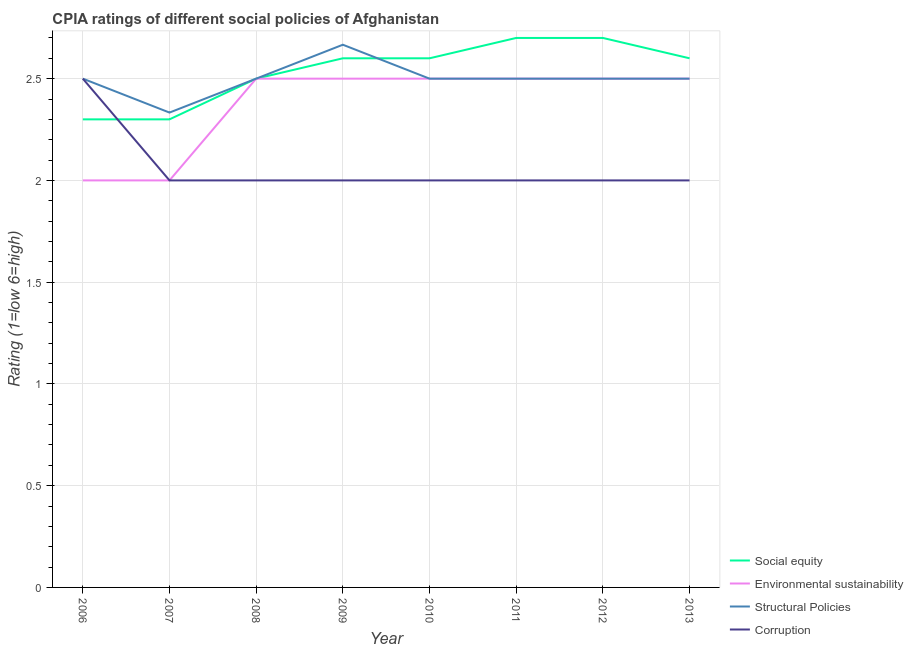Does the line corresponding to cpia rating of environmental sustainability intersect with the line corresponding to cpia rating of structural policies?
Offer a terse response. Yes. In which year was the cpia rating of structural policies maximum?
Keep it short and to the point. 2009. In which year was the cpia rating of corruption minimum?
Your response must be concise. 2007. What is the total cpia rating of environmental sustainability in the graph?
Ensure brevity in your answer.  19. What is the difference between the cpia rating of structural policies in 2009 and that in 2010?
Keep it short and to the point. 0.17. What is the difference between the cpia rating of environmental sustainability in 2011 and the cpia rating of structural policies in 2009?
Make the answer very short. -0.17. What is the average cpia rating of corruption per year?
Keep it short and to the point. 2.06. In the year 2011, what is the difference between the cpia rating of structural policies and cpia rating of corruption?
Provide a short and direct response. 0.5. In how many years, is the cpia rating of social equity greater than 0.9?
Provide a succinct answer. 8. What is the ratio of the cpia rating of environmental sustainability in 2010 to that in 2012?
Your answer should be very brief. 1. What is the difference between the highest and the second highest cpia rating of social equity?
Provide a succinct answer. 0. What is the difference between the highest and the lowest cpia rating of social equity?
Offer a terse response. 0.4. Does the cpia rating of environmental sustainability monotonically increase over the years?
Your answer should be very brief. No. What is the difference between two consecutive major ticks on the Y-axis?
Provide a short and direct response. 0.5. Where does the legend appear in the graph?
Make the answer very short. Bottom right. How many legend labels are there?
Ensure brevity in your answer.  4. What is the title of the graph?
Ensure brevity in your answer.  CPIA ratings of different social policies of Afghanistan. Does "Grants and Revenue" appear as one of the legend labels in the graph?
Your response must be concise. No. What is the label or title of the Y-axis?
Give a very brief answer. Rating (1=low 6=high). What is the Rating (1=low 6=high) of Social equity in 2006?
Provide a short and direct response. 2.3. What is the Rating (1=low 6=high) in Environmental sustainability in 2006?
Provide a short and direct response. 2. What is the Rating (1=low 6=high) of Corruption in 2006?
Keep it short and to the point. 2.5. What is the Rating (1=low 6=high) in Environmental sustainability in 2007?
Offer a very short reply. 2. What is the Rating (1=low 6=high) in Structural Policies in 2007?
Provide a short and direct response. 2.33. What is the Rating (1=low 6=high) in Social equity in 2008?
Give a very brief answer. 2.5. What is the Rating (1=low 6=high) in Structural Policies in 2008?
Your response must be concise. 2.5. What is the Rating (1=low 6=high) of Corruption in 2008?
Provide a succinct answer. 2. What is the Rating (1=low 6=high) of Structural Policies in 2009?
Provide a succinct answer. 2.67. What is the Rating (1=low 6=high) in Corruption in 2009?
Ensure brevity in your answer.  2. What is the Rating (1=low 6=high) of Structural Policies in 2010?
Ensure brevity in your answer.  2.5. What is the Rating (1=low 6=high) in Corruption in 2010?
Provide a short and direct response. 2. What is the Rating (1=low 6=high) of Structural Policies in 2011?
Offer a terse response. 2.5. What is the Rating (1=low 6=high) of Social equity in 2012?
Provide a short and direct response. 2.7. What is the Rating (1=low 6=high) of Social equity in 2013?
Your response must be concise. 2.6. What is the Rating (1=low 6=high) in Corruption in 2013?
Ensure brevity in your answer.  2. Across all years, what is the maximum Rating (1=low 6=high) of Social equity?
Provide a short and direct response. 2.7. Across all years, what is the maximum Rating (1=low 6=high) in Environmental sustainability?
Offer a terse response. 2.5. Across all years, what is the maximum Rating (1=low 6=high) of Structural Policies?
Provide a short and direct response. 2.67. Across all years, what is the maximum Rating (1=low 6=high) of Corruption?
Offer a terse response. 2.5. Across all years, what is the minimum Rating (1=low 6=high) of Social equity?
Provide a succinct answer. 2.3. Across all years, what is the minimum Rating (1=low 6=high) of Environmental sustainability?
Make the answer very short. 2. Across all years, what is the minimum Rating (1=low 6=high) in Structural Policies?
Your answer should be compact. 2.33. Across all years, what is the minimum Rating (1=low 6=high) of Corruption?
Provide a short and direct response. 2. What is the total Rating (1=low 6=high) of Social equity in the graph?
Make the answer very short. 20.3. What is the total Rating (1=low 6=high) in Structural Policies in the graph?
Offer a very short reply. 20. What is the difference between the Rating (1=low 6=high) in Social equity in 2006 and that in 2007?
Make the answer very short. 0. What is the difference between the Rating (1=low 6=high) of Environmental sustainability in 2006 and that in 2007?
Give a very brief answer. 0. What is the difference between the Rating (1=low 6=high) in Corruption in 2006 and that in 2007?
Ensure brevity in your answer.  0.5. What is the difference between the Rating (1=low 6=high) of Environmental sustainability in 2006 and that in 2008?
Offer a very short reply. -0.5. What is the difference between the Rating (1=low 6=high) in Structural Policies in 2006 and that in 2008?
Provide a short and direct response. 0. What is the difference between the Rating (1=low 6=high) of Structural Policies in 2006 and that in 2009?
Your answer should be compact. -0.17. What is the difference between the Rating (1=low 6=high) of Social equity in 2006 and that in 2010?
Offer a very short reply. -0.3. What is the difference between the Rating (1=low 6=high) in Structural Policies in 2006 and that in 2010?
Offer a terse response. 0. What is the difference between the Rating (1=low 6=high) of Corruption in 2006 and that in 2011?
Make the answer very short. 0.5. What is the difference between the Rating (1=low 6=high) of Environmental sustainability in 2006 and that in 2012?
Your answer should be compact. -0.5. What is the difference between the Rating (1=low 6=high) of Corruption in 2006 and that in 2012?
Provide a succinct answer. 0.5. What is the difference between the Rating (1=low 6=high) in Social equity in 2006 and that in 2013?
Offer a terse response. -0.3. What is the difference between the Rating (1=low 6=high) in Structural Policies in 2006 and that in 2013?
Provide a succinct answer. 0. What is the difference between the Rating (1=low 6=high) in Corruption in 2006 and that in 2013?
Offer a very short reply. 0.5. What is the difference between the Rating (1=low 6=high) in Social equity in 2007 and that in 2009?
Give a very brief answer. -0.3. What is the difference between the Rating (1=low 6=high) in Structural Policies in 2007 and that in 2009?
Provide a succinct answer. -0.33. What is the difference between the Rating (1=low 6=high) in Corruption in 2007 and that in 2009?
Your answer should be very brief. 0. What is the difference between the Rating (1=low 6=high) of Social equity in 2007 and that in 2010?
Give a very brief answer. -0.3. What is the difference between the Rating (1=low 6=high) in Environmental sustainability in 2007 and that in 2010?
Ensure brevity in your answer.  -0.5. What is the difference between the Rating (1=low 6=high) of Social equity in 2007 and that in 2011?
Keep it short and to the point. -0.4. What is the difference between the Rating (1=low 6=high) of Social equity in 2007 and that in 2012?
Offer a terse response. -0.4. What is the difference between the Rating (1=low 6=high) in Environmental sustainability in 2007 and that in 2013?
Offer a very short reply. -0.5. What is the difference between the Rating (1=low 6=high) of Structural Policies in 2007 and that in 2013?
Your answer should be compact. -0.17. What is the difference between the Rating (1=low 6=high) in Social equity in 2008 and that in 2009?
Give a very brief answer. -0.1. What is the difference between the Rating (1=low 6=high) in Environmental sustainability in 2008 and that in 2009?
Offer a terse response. 0. What is the difference between the Rating (1=low 6=high) in Social equity in 2008 and that in 2010?
Your answer should be very brief. -0.1. What is the difference between the Rating (1=low 6=high) of Social equity in 2008 and that in 2011?
Your answer should be compact. -0.2. What is the difference between the Rating (1=low 6=high) in Corruption in 2008 and that in 2011?
Make the answer very short. 0. What is the difference between the Rating (1=low 6=high) of Social equity in 2008 and that in 2012?
Keep it short and to the point. -0.2. What is the difference between the Rating (1=low 6=high) of Social equity in 2008 and that in 2013?
Ensure brevity in your answer.  -0.1. What is the difference between the Rating (1=low 6=high) in Environmental sustainability in 2008 and that in 2013?
Your answer should be very brief. 0. What is the difference between the Rating (1=low 6=high) in Social equity in 2009 and that in 2010?
Provide a succinct answer. 0. What is the difference between the Rating (1=low 6=high) of Structural Policies in 2009 and that in 2010?
Your response must be concise. 0.17. What is the difference between the Rating (1=low 6=high) of Corruption in 2009 and that in 2010?
Your response must be concise. 0. What is the difference between the Rating (1=low 6=high) of Corruption in 2009 and that in 2011?
Give a very brief answer. 0. What is the difference between the Rating (1=low 6=high) of Environmental sustainability in 2009 and that in 2012?
Give a very brief answer. 0. What is the difference between the Rating (1=low 6=high) of Structural Policies in 2009 and that in 2012?
Your response must be concise. 0.17. What is the difference between the Rating (1=low 6=high) in Social equity in 2009 and that in 2013?
Your answer should be very brief. 0. What is the difference between the Rating (1=low 6=high) in Corruption in 2009 and that in 2013?
Your response must be concise. 0. What is the difference between the Rating (1=low 6=high) in Structural Policies in 2010 and that in 2011?
Your answer should be very brief. 0. What is the difference between the Rating (1=low 6=high) of Social equity in 2010 and that in 2012?
Offer a terse response. -0.1. What is the difference between the Rating (1=low 6=high) in Environmental sustainability in 2010 and that in 2012?
Your response must be concise. 0. What is the difference between the Rating (1=low 6=high) in Structural Policies in 2010 and that in 2012?
Your response must be concise. 0. What is the difference between the Rating (1=low 6=high) in Environmental sustainability in 2010 and that in 2013?
Offer a very short reply. 0. What is the difference between the Rating (1=low 6=high) of Social equity in 2011 and that in 2012?
Give a very brief answer. 0. What is the difference between the Rating (1=low 6=high) of Environmental sustainability in 2011 and that in 2012?
Make the answer very short. 0. What is the difference between the Rating (1=low 6=high) of Structural Policies in 2011 and that in 2012?
Your response must be concise. 0. What is the difference between the Rating (1=low 6=high) in Corruption in 2011 and that in 2012?
Make the answer very short. 0. What is the difference between the Rating (1=low 6=high) of Social equity in 2011 and that in 2013?
Offer a very short reply. 0.1. What is the difference between the Rating (1=low 6=high) in Environmental sustainability in 2011 and that in 2013?
Provide a succinct answer. 0. What is the difference between the Rating (1=low 6=high) of Structural Policies in 2011 and that in 2013?
Your answer should be compact. 0. What is the difference between the Rating (1=low 6=high) of Social equity in 2012 and that in 2013?
Offer a very short reply. 0.1. What is the difference between the Rating (1=low 6=high) of Social equity in 2006 and the Rating (1=low 6=high) of Environmental sustainability in 2007?
Provide a short and direct response. 0.3. What is the difference between the Rating (1=low 6=high) of Social equity in 2006 and the Rating (1=low 6=high) of Structural Policies in 2007?
Your answer should be very brief. -0.03. What is the difference between the Rating (1=low 6=high) of Social equity in 2006 and the Rating (1=low 6=high) of Corruption in 2007?
Your response must be concise. 0.3. What is the difference between the Rating (1=low 6=high) of Environmental sustainability in 2006 and the Rating (1=low 6=high) of Structural Policies in 2007?
Offer a terse response. -0.33. What is the difference between the Rating (1=low 6=high) of Environmental sustainability in 2006 and the Rating (1=low 6=high) of Corruption in 2007?
Your response must be concise. 0. What is the difference between the Rating (1=low 6=high) in Social equity in 2006 and the Rating (1=low 6=high) in Corruption in 2008?
Your response must be concise. 0.3. What is the difference between the Rating (1=low 6=high) in Environmental sustainability in 2006 and the Rating (1=low 6=high) in Structural Policies in 2008?
Provide a short and direct response. -0.5. What is the difference between the Rating (1=low 6=high) in Environmental sustainability in 2006 and the Rating (1=low 6=high) in Corruption in 2008?
Give a very brief answer. 0. What is the difference between the Rating (1=low 6=high) in Social equity in 2006 and the Rating (1=low 6=high) in Environmental sustainability in 2009?
Keep it short and to the point. -0.2. What is the difference between the Rating (1=low 6=high) of Social equity in 2006 and the Rating (1=low 6=high) of Structural Policies in 2009?
Your answer should be compact. -0.37. What is the difference between the Rating (1=low 6=high) of Social equity in 2006 and the Rating (1=low 6=high) of Corruption in 2009?
Your response must be concise. 0.3. What is the difference between the Rating (1=low 6=high) of Structural Policies in 2006 and the Rating (1=low 6=high) of Corruption in 2009?
Offer a very short reply. 0.5. What is the difference between the Rating (1=low 6=high) in Social equity in 2006 and the Rating (1=low 6=high) in Environmental sustainability in 2010?
Your answer should be compact. -0.2. What is the difference between the Rating (1=low 6=high) of Social equity in 2006 and the Rating (1=low 6=high) of Structural Policies in 2010?
Provide a succinct answer. -0.2. What is the difference between the Rating (1=low 6=high) in Social equity in 2006 and the Rating (1=low 6=high) in Corruption in 2010?
Provide a short and direct response. 0.3. What is the difference between the Rating (1=low 6=high) in Environmental sustainability in 2006 and the Rating (1=low 6=high) in Corruption in 2010?
Your response must be concise. 0. What is the difference between the Rating (1=low 6=high) of Structural Policies in 2006 and the Rating (1=low 6=high) of Corruption in 2010?
Your response must be concise. 0.5. What is the difference between the Rating (1=low 6=high) of Social equity in 2006 and the Rating (1=low 6=high) of Environmental sustainability in 2011?
Ensure brevity in your answer.  -0.2. What is the difference between the Rating (1=low 6=high) in Social equity in 2006 and the Rating (1=low 6=high) in Structural Policies in 2011?
Keep it short and to the point. -0.2. What is the difference between the Rating (1=low 6=high) of Social equity in 2006 and the Rating (1=low 6=high) of Corruption in 2011?
Offer a very short reply. 0.3. What is the difference between the Rating (1=low 6=high) in Environmental sustainability in 2006 and the Rating (1=low 6=high) in Structural Policies in 2011?
Keep it short and to the point. -0.5. What is the difference between the Rating (1=low 6=high) in Social equity in 2006 and the Rating (1=low 6=high) in Structural Policies in 2012?
Ensure brevity in your answer.  -0.2. What is the difference between the Rating (1=low 6=high) in Structural Policies in 2006 and the Rating (1=low 6=high) in Corruption in 2012?
Offer a very short reply. 0.5. What is the difference between the Rating (1=low 6=high) in Social equity in 2006 and the Rating (1=low 6=high) in Environmental sustainability in 2013?
Give a very brief answer. -0.2. What is the difference between the Rating (1=low 6=high) in Environmental sustainability in 2006 and the Rating (1=low 6=high) in Structural Policies in 2013?
Give a very brief answer. -0.5. What is the difference between the Rating (1=low 6=high) in Social equity in 2007 and the Rating (1=low 6=high) in Structural Policies in 2008?
Offer a terse response. -0.2. What is the difference between the Rating (1=low 6=high) of Social equity in 2007 and the Rating (1=low 6=high) of Corruption in 2008?
Offer a terse response. 0.3. What is the difference between the Rating (1=low 6=high) in Social equity in 2007 and the Rating (1=low 6=high) in Structural Policies in 2009?
Keep it short and to the point. -0.37. What is the difference between the Rating (1=low 6=high) in Environmental sustainability in 2007 and the Rating (1=low 6=high) in Corruption in 2009?
Ensure brevity in your answer.  0. What is the difference between the Rating (1=low 6=high) in Structural Policies in 2007 and the Rating (1=low 6=high) in Corruption in 2009?
Offer a terse response. 0.33. What is the difference between the Rating (1=low 6=high) of Social equity in 2007 and the Rating (1=low 6=high) of Environmental sustainability in 2010?
Give a very brief answer. -0.2. What is the difference between the Rating (1=low 6=high) in Environmental sustainability in 2007 and the Rating (1=low 6=high) in Structural Policies in 2010?
Make the answer very short. -0.5. What is the difference between the Rating (1=low 6=high) of Environmental sustainability in 2007 and the Rating (1=low 6=high) of Corruption in 2010?
Your answer should be very brief. 0. What is the difference between the Rating (1=low 6=high) in Structural Policies in 2007 and the Rating (1=low 6=high) in Corruption in 2010?
Offer a terse response. 0.33. What is the difference between the Rating (1=low 6=high) of Social equity in 2007 and the Rating (1=low 6=high) of Environmental sustainability in 2011?
Provide a short and direct response. -0.2. What is the difference between the Rating (1=low 6=high) in Structural Policies in 2007 and the Rating (1=low 6=high) in Corruption in 2011?
Your response must be concise. 0.33. What is the difference between the Rating (1=low 6=high) in Social equity in 2007 and the Rating (1=low 6=high) in Environmental sustainability in 2012?
Give a very brief answer. -0.2. What is the difference between the Rating (1=low 6=high) in Social equity in 2007 and the Rating (1=low 6=high) in Structural Policies in 2012?
Make the answer very short. -0.2. What is the difference between the Rating (1=low 6=high) of Social equity in 2007 and the Rating (1=low 6=high) of Corruption in 2012?
Provide a succinct answer. 0.3. What is the difference between the Rating (1=low 6=high) of Environmental sustainability in 2007 and the Rating (1=low 6=high) of Structural Policies in 2012?
Your response must be concise. -0.5. What is the difference between the Rating (1=low 6=high) of Environmental sustainability in 2007 and the Rating (1=low 6=high) of Corruption in 2012?
Keep it short and to the point. 0. What is the difference between the Rating (1=low 6=high) of Structural Policies in 2007 and the Rating (1=low 6=high) of Corruption in 2012?
Provide a short and direct response. 0.33. What is the difference between the Rating (1=low 6=high) in Social equity in 2007 and the Rating (1=low 6=high) in Environmental sustainability in 2013?
Give a very brief answer. -0.2. What is the difference between the Rating (1=low 6=high) of Social equity in 2007 and the Rating (1=low 6=high) of Structural Policies in 2013?
Provide a succinct answer. -0.2. What is the difference between the Rating (1=low 6=high) of Social equity in 2007 and the Rating (1=low 6=high) of Corruption in 2013?
Give a very brief answer. 0.3. What is the difference between the Rating (1=low 6=high) in Environmental sustainability in 2007 and the Rating (1=low 6=high) in Structural Policies in 2013?
Provide a succinct answer. -0.5. What is the difference between the Rating (1=low 6=high) in Social equity in 2008 and the Rating (1=low 6=high) in Structural Policies in 2009?
Ensure brevity in your answer.  -0.17. What is the difference between the Rating (1=low 6=high) of Environmental sustainability in 2008 and the Rating (1=low 6=high) of Corruption in 2009?
Give a very brief answer. 0.5. What is the difference between the Rating (1=low 6=high) in Structural Policies in 2008 and the Rating (1=low 6=high) in Corruption in 2009?
Your answer should be compact. 0.5. What is the difference between the Rating (1=low 6=high) in Social equity in 2008 and the Rating (1=low 6=high) in Environmental sustainability in 2010?
Provide a succinct answer. 0. What is the difference between the Rating (1=low 6=high) of Environmental sustainability in 2008 and the Rating (1=low 6=high) of Structural Policies in 2010?
Your response must be concise. 0. What is the difference between the Rating (1=low 6=high) of Environmental sustainability in 2008 and the Rating (1=low 6=high) of Corruption in 2010?
Your answer should be compact. 0.5. What is the difference between the Rating (1=low 6=high) of Social equity in 2008 and the Rating (1=low 6=high) of Environmental sustainability in 2011?
Ensure brevity in your answer.  0. What is the difference between the Rating (1=low 6=high) in Social equity in 2008 and the Rating (1=low 6=high) in Corruption in 2011?
Your response must be concise. 0.5. What is the difference between the Rating (1=low 6=high) of Environmental sustainability in 2008 and the Rating (1=low 6=high) of Structural Policies in 2011?
Offer a very short reply. 0. What is the difference between the Rating (1=low 6=high) of Environmental sustainability in 2008 and the Rating (1=low 6=high) of Corruption in 2011?
Provide a succinct answer. 0.5. What is the difference between the Rating (1=low 6=high) in Environmental sustainability in 2008 and the Rating (1=low 6=high) in Structural Policies in 2012?
Your response must be concise. 0. What is the difference between the Rating (1=low 6=high) of Environmental sustainability in 2008 and the Rating (1=low 6=high) of Corruption in 2012?
Offer a terse response. 0.5. What is the difference between the Rating (1=low 6=high) in Structural Policies in 2008 and the Rating (1=low 6=high) in Corruption in 2012?
Keep it short and to the point. 0.5. What is the difference between the Rating (1=low 6=high) of Social equity in 2008 and the Rating (1=low 6=high) of Environmental sustainability in 2013?
Provide a succinct answer. 0. What is the difference between the Rating (1=low 6=high) in Social equity in 2008 and the Rating (1=low 6=high) in Corruption in 2013?
Provide a short and direct response. 0.5. What is the difference between the Rating (1=low 6=high) in Environmental sustainability in 2009 and the Rating (1=low 6=high) in Structural Policies in 2010?
Your response must be concise. 0. What is the difference between the Rating (1=low 6=high) in Structural Policies in 2009 and the Rating (1=low 6=high) in Corruption in 2010?
Your answer should be compact. 0.67. What is the difference between the Rating (1=low 6=high) of Social equity in 2009 and the Rating (1=low 6=high) of Structural Policies in 2011?
Make the answer very short. 0.1. What is the difference between the Rating (1=low 6=high) in Social equity in 2009 and the Rating (1=low 6=high) in Corruption in 2011?
Ensure brevity in your answer.  0.6. What is the difference between the Rating (1=low 6=high) of Structural Policies in 2009 and the Rating (1=low 6=high) of Corruption in 2011?
Ensure brevity in your answer.  0.67. What is the difference between the Rating (1=low 6=high) of Social equity in 2009 and the Rating (1=low 6=high) of Environmental sustainability in 2012?
Make the answer very short. 0.1. What is the difference between the Rating (1=low 6=high) of Environmental sustainability in 2009 and the Rating (1=low 6=high) of Corruption in 2012?
Provide a short and direct response. 0.5. What is the difference between the Rating (1=low 6=high) in Structural Policies in 2009 and the Rating (1=low 6=high) in Corruption in 2012?
Provide a succinct answer. 0.67. What is the difference between the Rating (1=low 6=high) of Social equity in 2009 and the Rating (1=low 6=high) of Environmental sustainability in 2013?
Provide a short and direct response. 0.1. What is the difference between the Rating (1=low 6=high) in Environmental sustainability in 2009 and the Rating (1=low 6=high) in Corruption in 2013?
Provide a short and direct response. 0.5. What is the difference between the Rating (1=low 6=high) of Structural Policies in 2009 and the Rating (1=low 6=high) of Corruption in 2013?
Make the answer very short. 0.67. What is the difference between the Rating (1=low 6=high) of Social equity in 2010 and the Rating (1=low 6=high) of Structural Policies in 2011?
Ensure brevity in your answer.  0.1. What is the difference between the Rating (1=low 6=high) in Social equity in 2010 and the Rating (1=low 6=high) in Corruption in 2011?
Your answer should be very brief. 0.6. What is the difference between the Rating (1=low 6=high) in Environmental sustainability in 2010 and the Rating (1=low 6=high) in Structural Policies in 2011?
Give a very brief answer. 0. What is the difference between the Rating (1=low 6=high) in Social equity in 2010 and the Rating (1=low 6=high) in Environmental sustainability in 2012?
Make the answer very short. 0.1. What is the difference between the Rating (1=low 6=high) in Social equity in 2010 and the Rating (1=low 6=high) in Structural Policies in 2012?
Make the answer very short. 0.1. What is the difference between the Rating (1=low 6=high) in Environmental sustainability in 2010 and the Rating (1=low 6=high) in Structural Policies in 2012?
Offer a terse response. 0. What is the difference between the Rating (1=low 6=high) of Environmental sustainability in 2010 and the Rating (1=low 6=high) of Corruption in 2012?
Give a very brief answer. 0.5. What is the difference between the Rating (1=low 6=high) of Social equity in 2010 and the Rating (1=low 6=high) of Environmental sustainability in 2013?
Ensure brevity in your answer.  0.1. What is the difference between the Rating (1=low 6=high) of Social equity in 2010 and the Rating (1=low 6=high) of Structural Policies in 2013?
Offer a very short reply. 0.1. What is the difference between the Rating (1=low 6=high) of Social equity in 2010 and the Rating (1=low 6=high) of Corruption in 2013?
Provide a succinct answer. 0.6. What is the difference between the Rating (1=low 6=high) in Structural Policies in 2010 and the Rating (1=low 6=high) in Corruption in 2013?
Your response must be concise. 0.5. What is the difference between the Rating (1=low 6=high) of Social equity in 2011 and the Rating (1=low 6=high) of Structural Policies in 2012?
Your answer should be compact. 0.2. What is the difference between the Rating (1=low 6=high) in Environmental sustainability in 2011 and the Rating (1=low 6=high) in Structural Policies in 2012?
Ensure brevity in your answer.  0. What is the difference between the Rating (1=low 6=high) in Environmental sustainability in 2011 and the Rating (1=low 6=high) in Structural Policies in 2013?
Ensure brevity in your answer.  0. What is the difference between the Rating (1=low 6=high) of Structural Policies in 2011 and the Rating (1=low 6=high) of Corruption in 2013?
Provide a succinct answer. 0.5. What is the difference between the Rating (1=low 6=high) in Social equity in 2012 and the Rating (1=low 6=high) in Structural Policies in 2013?
Provide a succinct answer. 0.2. What is the difference between the Rating (1=low 6=high) in Social equity in 2012 and the Rating (1=low 6=high) in Corruption in 2013?
Your response must be concise. 0.7. What is the difference between the Rating (1=low 6=high) in Environmental sustainability in 2012 and the Rating (1=low 6=high) in Structural Policies in 2013?
Your answer should be very brief. 0. What is the difference between the Rating (1=low 6=high) of Environmental sustainability in 2012 and the Rating (1=low 6=high) of Corruption in 2013?
Provide a succinct answer. 0.5. What is the average Rating (1=low 6=high) in Social equity per year?
Provide a short and direct response. 2.54. What is the average Rating (1=low 6=high) in Environmental sustainability per year?
Provide a short and direct response. 2.38. What is the average Rating (1=low 6=high) of Corruption per year?
Keep it short and to the point. 2.06. In the year 2006, what is the difference between the Rating (1=low 6=high) of Social equity and Rating (1=low 6=high) of Corruption?
Offer a terse response. -0.2. In the year 2006, what is the difference between the Rating (1=low 6=high) of Environmental sustainability and Rating (1=low 6=high) of Corruption?
Your answer should be very brief. -0.5. In the year 2007, what is the difference between the Rating (1=low 6=high) of Social equity and Rating (1=low 6=high) of Environmental sustainability?
Your response must be concise. 0.3. In the year 2007, what is the difference between the Rating (1=low 6=high) in Social equity and Rating (1=low 6=high) in Structural Policies?
Your answer should be very brief. -0.03. In the year 2007, what is the difference between the Rating (1=low 6=high) of Environmental sustainability and Rating (1=low 6=high) of Corruption?
Your answer should be compact. 0. In the year 2007, what is the difference between the Rating (1=low 6=high) in Structural Policies and Rating (1=low 6=high) in Corruption?
Give a very brief answer. 0.33. In the year 2008, what is the difference between the Rating (1=low 6=high) in Social equity and Rating (1=low 6=high) in Corruption?
Ensure brevity in your answer.  0.5. In the year 2008, what is the difference between the Rating (1=low 6=high) of Structural Policies and Rating (1=low 6=high) of Corruption?
Provide a succinct answer. 0.5. In the year 2009, what is the difference between the Rating (1=low 6=high) of Social equity and Rating (1=low 6=high) of Environmental sustainability?
Your answer should be very brief. 0.1. In the year 2009, what is the difference between the Rating (1=low 6=high) in Social equity and Rating (1=low 6=high) in Structural Policies?
Ensure brevity in your answer.  -0.07. In the year 2009, what is the difference between the Rating (1=low 6=high) of Environmental sustainability and Rating (1=low 6=high) of Corruption?
Offer a terse response. 0.5. In the year 2009, what is the difference between the Rating (1=low 6=high) in Structural Policies and Rating (1=low 6=high) in Corruption?
Provide a succinct answer. 0.67. In the year 2010, what is the difference between the Rating (1=low 6=high) in Structural Policies and Rating (1=low 6=high) in Corruption?
Your answer should be compact. 0.5. In the year 2011, what is the difference between the Rating (1=low 6=high) in Social equity and Rating (1=low 6=high) in Environmental sustainability?
Provide a short and direct response. 0.2. In the year 2011, what is the difference between the Rating (1=low 6=high) of Social equity and Rating (1=low 6=high) of Structural Policies?
Keep it short and to the point. 0.2. In the year 2011, what is the difference between the Rating (1=low 6=high) of Social equity and Rating (1=low 6=high) of Corruption?
Make the answer very short. 0.7. In the year 2012, what is the difference between the Rating (1=low 6=high) in Social equity and Rating (1=low 6=high) in Environmental sustainability?
Ensure brevity in your answer.  0.2. In the year 2012, what is the difference between the Rating (1=low 6=high) in Social equity and Rating (1=low 6=high) in Structural Policies?
Offer a terse response. 0.2. In the year 2012, what is the difference between the Rating (1=low 6=high) in Social equity and Rating (1=low 6=high) in Corruption?
Provide a short and direct response. 0.7. In the year 2012, what is the difference between the Rating (1=low 6=high) of Environmental sustainability and Rating (1=low 6=high) of Structural Policies?
Keep it short and to the point. 0. In the year 2013, what is the difference between the Rating (1=low 6=high) in Social equity and Rating (1=low 6=high) in Environmental sustainability?
Ensure brevity in your answer.  0.1. In the year 2013, what is the difference between the Rating (1=low 6=high) in Social equity and Rating (1=low 6=high) in Structural Policies?
Provide a short and direct response. 0.1. In the year 2013, what is the difference between the Rating (1=low 6=high) of Environmental sustainability and Rating (1=low 6=high) of Structural Policies?
Ensure brevity in your answer.  0. What is the ratio of the Rating (1=low 6=high) of Social equity in 2006 to that in 2007?
Make the answer very short. 1. What is the ratio of the Rating (1=low 6=high) in Structural Policies in 2006 to that in 2007?
Provide a succinct answer. 1.07. What is the ratio of the Rating (1=low 6=high) of Corruption in 2006 to that in 2007?
Your answer should be compact. 1.25. What is the ratio of the Rating (1=low 6=high) in Structural Policies in 2006 to that in 2008?
Ensure brevity in your answer.  1. What is the ratio of the Rating (1=low 6=high) in Corruption in 2006 to that in 2008?
Give a very brief answer. 1.25. What is the ratio of the Rating (1=low 6=high) in Social equity in 2006 to that in 2009?
Your answer should be compact. 0.88. What is the ratio of the Rating (1=low 6=high) in Structural Policies in 2006 to that in 2009?
Give a very brief answer. 0.94. What is the ratio of the Rating (1=low 6=high) in Social equity in 2006 to that in 2010?
Offer a very short reply. 0.88. What is the ratio of the Rating (1=low 6=high) in Structural Policies in 2006 to that in 2010?
Provide a succinct answer. 1. What is the ratio of the Rating (1=low 6=high) of Social equity in 2006 to that in 2011?
Offer a terse response. 0.85. What is the ratio of the Rating (1=low 6=high) of Environmental sustainability in 2006 to that in 2011?
Make the answer very short. 0.8. What is the ratio of the Rating (1=low 6=high) in Structural Policies in 2006 to that in 2011?
Your response must be concise. 1. What is the ratio of the Rating (1=low 6=high) in Social equity in 2006 to that in 2012?
Your response must be concise. 0.85. What is the ratio of the Rating (1=low 6=high) of Environmental sustainability in 2006 to that in 2012?
Give a very brief answer. 0.8. What is the ratio of the Rating (1=low 6=high) of Structural Policies in 2006 to that in 2012?
Provide a succinct answer. 1. What is the ratio of the Rating (1=low 6=high) in Social equity in 2006 to that in 2013?
Offer a terse response. 0.88. What is the ratio of the Rating (1=low 6=high) in Corruption in 2006 to that in 2013?
Provide a short and direct response. 1.25. What is the ratio of the Rating (1=low 6=high) in Social equity in 2007 to that in 2008?
Offer a very short reply. 0.92. What is the ratio of the Rating (1=low 6=high) of Environmental sustainability in 2007 to that in 2008?
Your response must be concise. 0.8. What is the ratio of the Rating (1=low 6=high) in Structural Policies in 2007 to that in 2008?
Provide a short and direct response. 0.93. What is the ratio of the Rating (1=low 6=high) in Social equity in 2007 to that in 2009?
Ensure brevity in your answer.  0.88. What is the ratio of the Rating (1=low 6=high) in Environmental sustainability in 2007 to that in 2009?
Provide a short and direct response. 0.8. What is the ratio of the Rating (1=low 6=high) of Structural Policies in 2007 to that in 2009?
Your response must be concise. 0.88. What is the ratio of the Rating (1=low 6=high) in Corruption in 2007 to that in 2009?
Give a very brief answer. 1. What is the ratio of the Rating (1=low 6=high) in Social equity in 2007 to that in 2010?
Your answer should be compact. 0.88. What is the ratio of the Rating (1=low 6=high) of Environmental sustainability in 2007 to that in 2010?
Make the answer very short. 0.8. What is the ratio of the Rating (1=low 6=high) in Social equity in 2007 to that in 2011?
Your answer should be compact. 0.85. What is the ratio of the Rating (1=low 6=high) of Environmental sustainability in 2007 to that in 2011?
Make the answer very short. 0.8. What is the ratio of the Rating (1=low 6=high) of Structural Policies in 2007 to that in 2011?
Make the answer very short. 0.93. What is the ratio of the Rating (1=low 6=high) of Corruption in 2007 to that in 2011?
Your answer should be very brief. 1. What is the ratio of the Rating (1=low 6=high) in Social equity in 2007 to that in 2012?
Ensure brevity in your answer.  0.85. What is the ratio of the Rating (1=low 6=high) of Corruption in 2007 to that in 2012?
Make the answer very short. 1. What is the ratio of the Rating (1=low 6=high) of Social equity in 2007 to that in 2013?
Provide a succinct answer. 0.88. What is the ratio of the Rating (1=low 6=high) in Structural Policies in 2007 to that in 2013?
Your response must be concise. 0.93. What is the ratio of the Rating (1=low 6=high) in Corruption in 2007 to that in 2013?
Provide a short and direct response. 1. What is the ratio of the Rating (1=low 6=high) of Social equity in 2008 to that in 2009?
Offer a terse response. 0.96. What is the ratio of the Rating (1=low 6=high) in Structural Policies in 2008 to that in 2009?
Offer a terse response. 0.94. What is the ratio of the Rating (1=low 6=high) of Corruption in 2008 to that in 2009?
Your answer should be compact. 1. What is the ratio of the Rating (1=low 6=high) of Social equity in 2008 to that in 2010?
Give a very brief answer. 0.96. What is the ratio of the Rating (1=low 6=high) of Environmental sustainability in 2008 to that in 2010?
Offer a terse response. 1. What is the ratio of the Rating (1=low 6=high) in Structural Policies in 2008 to that in 2010?
Ensure brevity in your answer.  1. What is the ratio of the Rating (1=low 6=high) of Social equity in 2008 to that in 2011?
Give a very brief answer. 0.93. What is the ratio of the Rating (1=low 6=high) in Structural Policies in 2008 to that in 2011?
Offer a very short reply. 1. What is the ratio of the Rating (1=low 6=high) of Social equity in 2008 to that in 2012?
Make the answer very short. 0.93. What is the ratio of the Rating (1=low 6=high) of Structural Policies in 2008 to that in 2012?
Make the answer very short. 1. What is the ratio of the Rating (1=low 6=high) in Social equity in 2008 to that in 2013?
Give a very brief answer. 0.96. What is the ratio of the Rating (1=low 6=high) of Environmental sustainability in 2008 to that in 2013?
Provide a short and direct response. 1. What is the ratio of the Rating (1=low 6=high) of Structural Policies in 2008 to that in 2013?
Keep it short and to the point. 1. What is the ratio of the Rating (1=low 6=high) of Social equity in 2009 to that in 2010?
Make the answer very short. 1. What is the ratio of the Rating (1=low 6=high) of Structural Policies in 2009 to that in 2010?
Your answer should be very brief. 1.07. What is the ratio of the Rating (1=low 6=high) in Social equity in 2009 to that in 2011?
Offer a terse response. 0.96. What is the ratio of the Rating (1=low 6=high) of Environmental sustainability in 2009 to that in 2011?
Keep it short and to the point. 1. What is the ratio of the Rating (1=low 6=high) of Structural Policies in 2009 to that in 2011?
Provide a succinct answer. 1.07. What is the ratio of the Rating (1=low 6=high) of Corruption in 2009 to that in 2011?
Provide a short and direct response. 1. What is the ratio of the Rating (1=low 6=high) of Social equity in 2009 to that in 2012?
Make the answer very short. 0.96. What is the ratio of the Rating (1=low 6=high) in Structural Policies in 2009 to that in 2012?
Keep it short and to the point. 1.07. What is the ratio of the Rating (1=low 6=high) of Corruption in 2009 to that in 2012?
Your response must be concise. 1. What is the ratio of the Rating (1=low 6=high) of Social equity in 2009 to that in 2013?
Give a very brief answer. 1. What is the ratio of the Rating (1=low 6=high) in Environmental sustainability in 2009 to that in 2013?
Your answer should be very brief. 1. What is the ratio of the Rating (1=low 6=high) of Structural Policies in 2009 to that in 2013?
Offer a terse response. 1.07. What is the ratio of the Rating (1=low 6=high) of Social equity in 2010 to that in 2011?
Make the answer very short. 0.96. What is the ratio of the Rating (1=low 6=high) in Environmental sustainability in 2010 to that in 2011?
Your answer should be very brief. 1. What is the ratio of the Rating (1=low 6=high) in Social equity in 2010 to that in 2012?
Make the answer very short. 0.96. What is the ratio of the Rating (1=low 6=high) of Environmental sustainability in 2010 to that in 2012?
Offer a terse response. 1. What is the ratio of the Rating (1=low 6=high) in Social equity in 2010 to that in 2013?
Your response must be concise. 1. What is the ratio of the Rating (1=low 6=high) in Structural Policies in 2010 to that in 2013?
Make the answer very short. 1. What is the ratio of the Rating (1=low 6=high) of Corruption in 2010 to that in 2013?
Your answer should be compact. 1. What is the ratio of the Rating (1=low 6=high) of Environmental sustainability in 2011 to that in 2012?
Make the answer very short. 1. What is the ratio of the Rating (1=low 6=high) of Structural Policies in 2011 to that in 2012?
Give a very brief answer. 1. What is the ratio of the Rating (1=low 6=high) of Corruption in 2011 to that in 2012?
Your answer should be compact. 1. What is the ratio of the Rating (1=low 6=high) of Environmental sustainability in 2011 to that in 2013?
Offer a terse response. 1. What is the ratio of the Rating (1=low 6=high) in Social equity in 2012 to that in 2013?
Give a very brief answer. 1.04. What is the difference between the highest and the second highest Rating (1=low 6=high) of Structural Policies?
Your response must be concise. 0.17. What is the difference between the highest and the second highest Rating (1=low 6=high) of Corruption?
Make the answer very short. 0.5. What is the difference between the highest and the lowest Rating (1=low 6=high) of Social equity?
Keep it short and to the point. 0.4. What is the difference between the highest and the lowest Rating (1=low 6=high) of Environmental sustainability?
Keep it short and to the point. 0.5. What is the difference between the highest and the lowest Rating (1=low 6=high) in Structural Policies?
Ensure brevity in your answer.  0.33. What is the difference between the highest and the lowest Rating (1=low 6=high) in Corruption?
Ensure brevity in your answer.  0.5. 